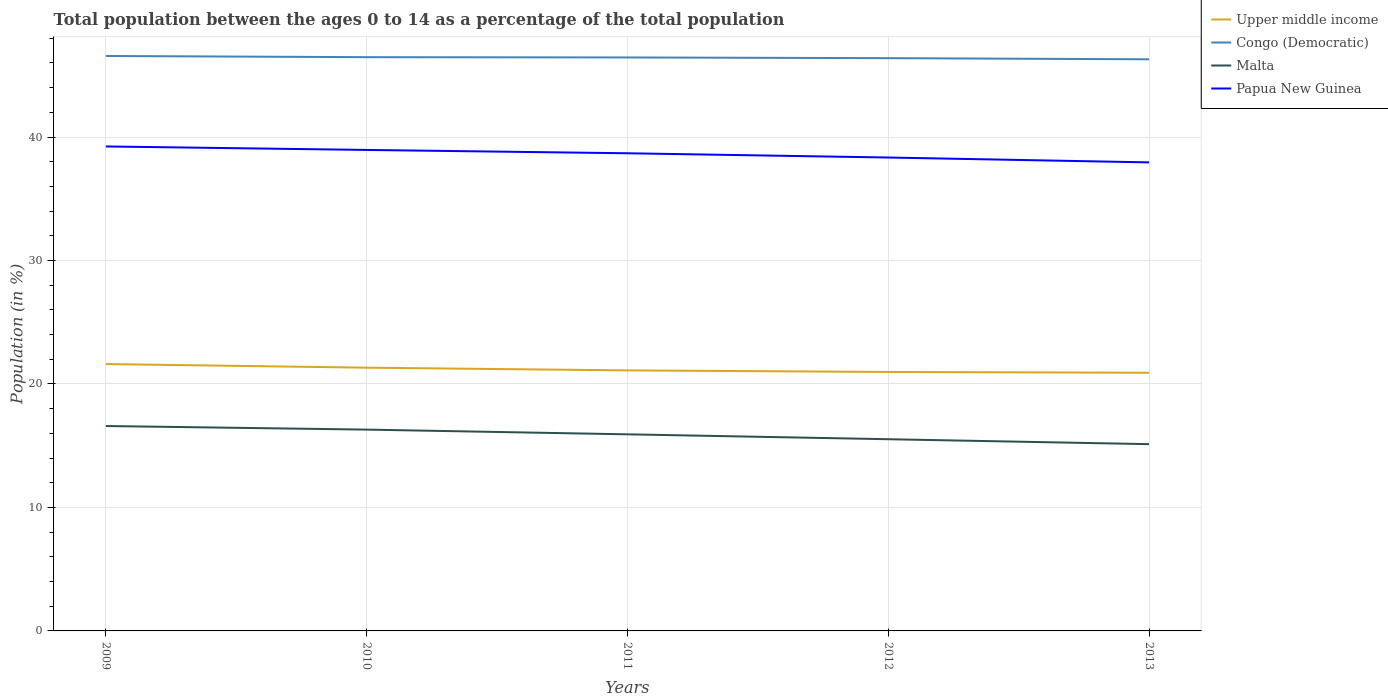Is the number of lines equal to the number of legend labels?
Your answer should be very brief. Yes. Across all years, what is the maximum percentage of the population ages 0 to 14 in Malta?
Keep it short and to the point. 15.13. What is the total percentage of the population ages 0 to 14 in Upper middle income in the graph?
Give a very brief answer. 0.7. What is the difference between the highest and the second highest percentage of the population ages 0 to 14 in Malta?
Provide a succinct answer. 1.47. How many lines are there?
Offer a very short reply. 4. Does the graph contain any zero values?
Your response must be concise. No. Where does the legend appear in the graph?
Your response must be concise. Top right. How many legend labels are there?
Offer a very short reply. 4. How are the legend labels stacked?
Offer a very short reply. Vertical. What is the title of the graph?
Provide a succinct answer. Total population between the ages 0 to 14 as a percentage of the total population. What is the label or title of the X-axis?
Give a very brief answer. Years. What is the label or title of the Y-axis?
Give a very brief answer. Population (in %). What is the Population (in %) of Upper middle income in 2009?
Make the answer very short. 21.61. What is the Population (in %) of Congo (Democratic) in 2009?
Give a very brief answer. 46.56. What is the Population (in %) in Malta in 2009?
Provide a succinct answer. 16.6. What is the Population (in %) of Papua New Guinea in 2009?
Give a very brief answer. 39.24. What is the Population (in %) in Upper middle income in 2010?
Keep it short and to the point. 21.32. What is the Population (in %) in Congo (Democratic) in 2010?
Ensure brevity in your answer.  46.47. What is the Population (in %) in Malta in 2010?
Offer a terse response. 16.3. What is the Population (in %) in Papua New Guinea in 2010?
Make the answer very short. 38.95. What is the Population (in %) of Upper middle income in 2011?
Ensure brevity in your answer.  21.1. What is the Population (in %) of Congo (Democratic) in 2011?
Make the answer very short. 46.45. What is the Population (in %) of Malta in 2011?
Make the answer very short. 15.92. What is the Population (in %) in Papua New Guinea in 2011?
Your answer should be very brief. 38.69. What is the Population (in %) in Upper middle income in 2012?
Make the answer very short. 20.97. What is the Population (in %) of Congo (Democratic) in 2012?
Give a very brief answer. 46.39. What is the Population (in %) in Malta in 2012?
Make the answer very short. 15.53. What is the Population (in %) of Papua New Guinea in 2012?
Offer a terse response. 38.34. What is the Population (in %) in Upper middle income in 2013?
Give a very brief answer. 20.91. What is the Population (in %) in Congo (Democratic) in 2013?
Make the answer very short. 46.3. What is the Population (in %) in Malta in 2013?
Offer a very short reply. 15.13. What is the Population (in %) in Papua New Guinea in 2013?
Keep it short and to the point. 37.95. Across all years, what is the maximum Population (in %) of Upper middle income?
Keep it short and to the point. 21.61. Across all years, what is the maximum Population (in %) in Congo (Democratic)?
Your answer should be compact. 46.56. Across all years, what is the maximum Population (in %) of Malta?
Provide a succinct answer. 16.6. Across all years, what is the maximum Population (in %) in Papua New Guinea?
Ensure brevity in your answer.  39.24. Across all years, what is the minimum Population (in %) in Upper middle income?
Offer a very short reply. 20.91. Across all years, what is the minimum Population (in %) in Congo (Democratic)?
Ensure brevity in your answer.  46.3. Across all years, what is the minimum Population (in %) in Malta?
Give a very brief answer. 15.13. Across all years, what is the minimum Population (in %) in Papua New Guinea?
Ensure brevity in your answer.  37.95. What is the total Population (in %) in Upper middle income in the graph?
Offer a very short reply. 105.92. What is the total Population (in %) in Congo (Democratic) in the graph?
Provide a short and direct response. 232.16. What is the total Population (in %) of Malta in the graph?
Make the answer very short. 79.47. What is the total Population (in %) in Papua New Guinea in the graph?
Keep it short and to the point. 193.17. What is the difference between the Population (in %) in Upper middle income in 2009 and that in 2010?
Your answer should be compact. 0.29. What is the difference between the Population (in %) in Congo (Democratic) in 2009 and that in 2010?
Ensure brevity in your answer.  0.1. What is the difference between the Population (in %) of Malta in 2009 and that in 2010?
Make the answer very short. 0.29. What is the difference between the Population (in %) in Papua New Guinea in 2009 and that in 2010?
Keep it short and to the point. 0.28. What is the difference between the Population (in %) of Upper middle income in 2009 and that in 2011?
Ensure brevity in your answer.  0.51. What is the difference between the Population (in %) in Congo (Democratic) in 2009 and that in 2011?
Provide a succinct answer. 0.12. What is the difference between the Population (in %) in Malta in 2009 and that in 2011?
Offer a terse response. 0.67. What is the difference between the Population (in %) in Papua New Guinea in 2009 and that in 2011?
Give a very brief answer. 0.55. What is the difference between the Population (in %) of Upper middle income in 2009 and that in 2012?
Your answer should be compact. 0.64. What is the difference between the Population (in %) in Congo (Democratic) in 2009 and that in 2012?
Make the answer very short. 0.18. What is the difference between the Population (in %) in Malta in 2009 and that in 2012?
Provide a succinct answer. 1.07. What is the difference between the Population (in %) in Papua New Guinea in 2009 and that in 2012?
Ensure brevity in your answer.  0.9. What is the difference between the Population (in %) of Upper middle income in 2009 and that in 2013?
Your answer should be compact. 0.7. What is the difference between the Population (in %) in Congo (Democratic) in 2009 and that in 2013?
Keep it short and to the point. 0.27. What is the difference between the Population (in %) of Malta in 2009 and that in 2013?
Offer a terse response. 1.47. What is the difference between the Population (in %) in Papua New Guinea in 2009 and that in 2013?
Ensure brevity in your answer.  1.29. What is the difference between the Population (in %) in Upper middle income in 2010 and that in 2011?
Offer a very short reply. 0.22. What is the difference between the Population (in %) of Congo (Democratic) in 2010 and that in 2011?
Provide a short and direct response. 0.02. What is the difference between the Population (in %) of Malta in 2010 and that in 2011?
Your response must be concise. 0.38. What is the difference between the Population (in %) in Papua New Guinea in 2010 and that in 2011?
Provide a succinct answer. 0.27. What is the difference between the Population (in %) in Upper middle income in 2010 and that in 2012?
Provide a succinct answer. 0.35. What is the difference between the Population (in %) in Congo (Democratic) in 2010 and that in 2012?
Provide a succinct answer. 0.08. What is the difference between the Population (in %) of Malta in 2010 and that in 2012?
Offer a terse response. 0.78. What is the difference between the Population (in %) of Papua New Guinea in 2010 and that in 2012?
Your response must be concise. 0.61. What is the difference between the Population (in %) of Upper middle income in 2010 and that in 2013?
Your answer should be compact. 0.41. What is the difference between the Population (in %) in Congo (Democratic) in 2010 and that in 2013?
Ensure brevity in your answer.  0.17. What is the difference between the Population (in %) of Malta in 2010 and that in 2013?
Give a very brief answer. 1.18. What is the difference between the Population (in %) in Papua New Guinea in 2010 and that in 2013?
Your answer should be compact. 1.01. What is the difference between the Population (in %) of Upper middle income in 2011 and that in 2012?
Give a very brief answer. 0.13. What is the difference between the Population (in %) of Congo (Democratic) in 2011 and that in 2012?
Keep it short and to the point. 0.06. What is the difference between the Population (in %) of Malta in 2011 and that in 2012?
Your response must be concise. 0.4. What is the difference between the Population (in %) of Papua New Guinea in 2011 and that in 2012?
Make the answer very short. 0.34. What is the difference between the Population (in %) in Upper middle income in 2011 and that in 2013?
Your answer should be compact. 0.19. What is the difference between the Population (in %) of Congo (Democratic) in 2011 and that in 2013?
Offer a terse response. 0.15. What is the difference between the Population (in %) of Malta in 2011 and that in 2013?
Your answer should be very brief. 0.8. What is the difference between the Population (in %) in Papua New Guinea in 2011 and that in 2013?
Your answer should be compact. 0.74. What is the difference between the Population (in %) of Upper middle income in 2012 and that in 2013?
Your answer should be very brief. 0.06. What is the difference between the Population (in %) in Congo (Democratic) in 2012 and that in 2013?
Offer a very short reply. 0.09. What is the difference between the Population (in %) in Malta in 2012 and that in 2013?
Offer a terse response. 0.4. What is the difference between the Population (in %) in Papua New Guinea in 2012 and that in 2013?
Offer a terse response. 0.4. What is the difference between the Population (in %) of Upper middle income in 2009 and the Population (in %) of Congo (Democratic) in 2010?
Provide a short and direct response. -24.86. What is the difference between the Population (in %) in Upper middle income in 2009 and the Population (in %) in Malta in 2010?
Your answer should be very brief. 5.31. What is the difference between the Population (in %) of Upper middle income in 2009 and the Population (in %) of Papua New Guinea in 2010?
Your response must be concise. -17.34. What is the difference between the Population (in %) of Congo (Democratic) in 2009 and the Population (in %) of Malta in 2010?
Provide a short and direct response. 30.26. What is the difference between the Population (in %) in Congo (Democratic) in 2009 and the Population (in %) in Papua New Guinea in 2010?
Your answer should be compact. 7.61. What is the difference between the Population (in %) in Malta in 2009 and the Population (in %) in Papua New Guinea in 2010?
Your response must be concise. -22.36. What is the difference between the Population (in %) in Upper middle income in 2009 and the Population (in %) in Congo (Democratic) in 2011?
Give a very brief answer. -24.83. What is the difference between the Population (in %) of Upper middle income in 2009 and the Population (in %) of Malta in 2011?
Make the answer very short. 5.69. What is the difference between the Population (in %) in Upper middle income in 2009 and the Population (in %) in Papua New Guinea in 2011?
Make the answer very short. -17.07. What is the difference between the Population (in %) in Congo (Democratic) in 2009 and the Population (in %) in Malta in 2011?
Offer a very short reply. 30.64. What is the difference between the Population (in %) of Congo (Democratic) in 2009 and the Population (in %) of Papua New Guinea in 2011?
Provide a short and direct response. 7.88. What is the difference between the Population (in %) of Malta in 2009 and the Population (in %) of Papua New Guinea in 2011?
Offer a very short reply. -22.09. What is the difference between the Population (in %) in Upper middle income in 2009 and the Population (in %) in Congo (Democratic) in 2012?
Offer a terse response. -24.77. What is the difference between the Population (in %) in Upper middle income in 2009 and the Population (in %) in Malta in 2012?
Provide a succinct answer. 6.09. What is the difference between the Population (in %) in Upper middle income in 2009 and the Population (in %) in Papua New Guinea in 2012?
Your response must be concise. -16.73. What is the difference between the Population (in %) of Congo (Democratic) in 2009 and the Population (in %) of Malta in 2012?
Give a very brief answer. 31.04. What is the difference between the Population (in %) of Congo (Democratic) in 2009 and the Population (in %) of Papua New Guinea in 2012?
Provide a short and direct response. 8.22. What is the difference between the Population (in %) in Malta in 2009 and the Population (in %) in Papua New Guinea in 2012?
Your answer should be compact. -21.75. What is the difference between the Population (in %) in Upper middle income in 2009 and the Population (in %) in Congo (Democratic) in 2013?
Give a very brief answer. -24.68. What is the difference between the Population (in %) in Upper middle income in 2009 and the Population (in %) in Malta in 2013?
Offer a very short reply. 6.49. What is the difference between the Population (in %) of Upper middle income in 2009 and the Population (in %) of Papua New Guinea in 2013?
Keep it short and to the point. -16.33. What is the difference between the Population (in %) of Congo (Democratic) in 2009 and the Population (in %) of Malta in 2013?
Give a very brief answer. 31.44. What is the difference between the Population (in %) of Congo (Democratic) in 2009 and the Population (in %) of Papua New Guinea in 2013?
Provide a short and direct response. 8.62. What is the difference between the Population (in %) of Malta in 2009 and the Population (in %) of Papua New Guinea in 2013?
Provide a succinct answer. -21.35. What is the difference between the Population (in %) of Upper middle income in 2010 and the Population (in %) of Congo (Democratic) in 2011?
Offer a very short reply. -25.13. What is the difference between the Population (in %) in Upper middle income in 2010 and the Population (in %) in Malta in 2011?
Keep it short and to the point. 5.4. What is the difference between the Population (in %) of Upper middle income in 2010 and the Population (in %) of Papua New Guinea in 2011?
Give a very brief answer. -17.37. What is the difference between the Population (in %) in Congo (Democratic) in 2010 and the Population (in %) in Malta in 2011?
Your answer should be very brief. 30.55. What is the difference between the Population (in %) in Congo (Democratic) in 2010 and the Population (in %) in Papua New Guinea in 2011?
Make the answer very short. 7.78. What is the difference between the Population (in %) of Malta in 2010 and the Population (in %) of Papua New Guinea in 2011?
Provide a short and direct response. -22.38. What is the difference between the Population (in %) of Upper middle income in 2010 and the Population (in %) of Congo (Democratic) in 2012?
Your response must be concise. -25.07. What is the difference between the Population (in %) of Upper middle income in 2010 and the Population (in %) of Malta in 2012?
Make the answer very short. 5.79. What is the difference between the Population (in %) of Upper middle income in 2010 and the Population (in %) of Papua New Guinea in 2012?
Ensure brevity in your answer.  -17.02. What is the difference between the Population (in %) in Congo (Democratic) in 2010 and the Population (in %) in Malta in 2012?
Make the answer very short. 30.94. What is the difference between the Population (in %) of Congo (Democratic) in 2010 and the Population (in %) of Papua New Guinea in 2012?
Your answer should be very brief. 8.13. What is the difference between the Population (in %) of Malta in 2010 and the Population (in %) of Papua New Guinea in 2012?
Give a very brief answer. -22.04. What is the difference between the Population (in %) of Upper middle income in 2010 and the Population (in %) of Congo (Democratic) in 2013?
Provide a short and direct response. -24.98. What is the difference between the Population (in %) of Upper middle income in 2010 and the Population (in %) of Malta in 2013?
Your answer should be compact. 6.19. What is the difference between the Population (in %) of Upper middle income in 2010 and the Population (in %) of Papua New Guinea in 2013?
Provide a short and direct response. -16.63. What is the difference between the Population (in %) of Congo (Democratic) in 2010 and the Population (in %) of Malta in 2013?
Keep it short and to the point. 31.34. What is the difference between the Population (in %) of Congo (Democratic) in 2010 and the Population (in %) of Papua New Guinea in 2013?
Give a very brief answer. 8.52. What is the difference between the Population (in %) in Malta in 2010 and the Population (in %) in Papua New Guinea in 2013?
Keep it short and to the point. -21.64. What is the difference between the Population (in %) in Upper middle income in 2011 and the Population (in %) in Congo (Democratic) in 2012?
Keep it short and to the point. -25.29. What is the difference between the Population (in %) of Upper middle income in 2011 and the Population (in %) of Malta in 2012?
Make the answer very short. 5.57. What is the difference between the Population (in %) of Upper middle income in 2011 and the Population (in %) of Papua New Guinea in 2012?
Give a very brief answer. -17.24. What is the difference between the Population (in %) in Congo (Democratic) in 2011 and the Population (in %) in Malta in 2012?
Offer a very short reply. 30.92. What is the difference between the Population (in %) of Congo (Democratic) in 2011 and the Population (in %) of Papua New Guinea in 2012?
Offer a very short reply. 8.1. What is the difference between the Population (in %) in Malta in 2011 and the Population (in %) in Papua New Guinea in 2012?
Offer a terse response. -22.42. What is the difference between the Population (in %) of Upper middle income in 2011 and the Population (in %) of Congo (Democratic) in 2013?
Provide a succinct answer. -25.2. What is the difference between the Population (in %) of Upper middle income in 2011 and the Population (in %) of Malta in 2013?
Make the answer very short. 5.98. What is the difference between the Population (in %) of Upper middle income in 2011 and the Population (in %) of Papua New Guinea in 2013?
Give a very brief answer. -16.85. What is the difference between the Population (in %) in Congo (Democratic) in 2011 and the Population (in %) in Malta in 2013?
Your answer should be compact. 31.32. What is the difference between the Population (in %) of Congo (Democratic) in 2011 and the Population (in %) of Papua New Guinea in 2013?
Offer a terse response. 8.5. What is the difference between the Population (in %) of Malta in 2011 and the Population (in %) of Papua New Guinea in 2013?
Provide a short and direct response. -22.02. What is the difference between the Population (in %) in Upper middle income in 2012 and the Population (in %) in Congo (Democratic) in 2013?
Keep it short and to the point. -25.32. What is the difference between the Population (in %) of Upper middle income in 2012 and the Population (in %) of Malta in 2013?
Offer a terse response. 5.85. What is the difference between the Population (in %) in Upper middle income in 2012 and the Population (in %) in Papua New Guinea in 2013?
Give a very brief answer. -16.97. What is the difference between the Population (in %) of Congo (Democratic) in 2012 and the Population (in %) of Malta in 2013?
Keep it short and to the point. 31.26. What is the difference between the Population (in %) of Congo (Democratic) in 2012 and the Population (in %) of Papua New Guinea in 2013?
Make the answer very short. 8.44. What is the difference between the Population (in %) in Malta in 2012 and the Population (in %) in Papua New Guinea in 2013?
Give a very brief answer. -22.42. What is the average Population (in %) of Upper middle income per year?
Provide a short and direct response. 21.18. What is the average Population (in %) in Congo (Democratic) per year?
Ensure brevity in your answer.  46.43. What is the average Population (in %) in Malta per year?
Make the answer very short. 15.89. What is the average Population (in %) of Papua New Guinea per year?
Provide a short and direct response. 38.63. In the year 2009, what is the difference between the Population (in %) of Upper middle income and Population (in %) of Congo (Democratic)?
Make the answer very short. -24.95. In the year 2009, what is the difference between the Population (in %) of Upper middle income and Population (in %) of Malta?
Give a very brief answer. 5.02. In the year 2009, what is the difference between the Population (in %) in Upper middle income and Population (in %) in Papua New Guinea?
Make the answer very short. -17.62. In the year 2009, what is the difference between the Population (in %) in Congo (Democratic) and Population (in %) in Malta?
Your answer should be compact. 29.97. In the year 2009, what is the difference between the Population (in %) in Congo (Democratic) and Population (in %) in Papua New Guinea?
Give a very brief answer. 7.33. In the year 2009, what is the difference between the Population (in %) of Malta and Population (in %) of Papua New Guinea?
Provide a succinct answer. -22.64. In the year 2010, what is the difference between the Population (in %) of Upper middle income and Population (in %) of Congo (Democratic)?
Provide a succinct answer. -25.15. In the year 2010, what is the difference between the Population (in %) in Upper middle income and Population (in %) in Malta?
Offer a very short reply. 5.02. In the year 2010, what is the difference between the Population (in %) in Upper middle income and Population (in %) in Papua New Guinea?
Make the answer very short. -17.63. In the year 2010, what is the difference between the Population (in %) in Congo (Democratic) and Population (in %) in Malta?
Your answer should be very brief. 30.16. In the year 2010, what is the difference between the Population (in %) of Congo (Democratic) and Population (in %) of Papua New Guinea?
Provide a succinct answer. 7.51. In the year 2010, what is the difference between the Population (in %) in Malta and Population (in %) in Papua New Guinea?
Your answer should be compact. -22.65. In the year 2011, what is the difference between the Population (in %) of Upper middle income and Population (in %) of Congo (Democratic)?
Offer a terse response. -25.34. In the year 2011, what is the difference between the Population (in %) of Upper middle income and Population (in %) of Malta?
Offer a very short reply. 5.18. In the year 2011, what is the difference between the Population (in %) in Upper middle income and Population (in %) in Papua New Guinea?
Your answer should be compact. -17.59. In the year 2011, what is the difference between the Population (in %) in Congo (Democratic) and Population (in %) in Malta?
Make the answer very short. 30.52. In the year 2011, what is the difference between the Population (in %) in Congo (Democratic) and Population (in %) in Papua New Guinea?
Offer a terse response. 7.76. In the year 2011, what is the difference between the Population (in %) in Malta and Population (in %) in Papua New Guinea?
Ensure brevity in your answer.  -22.76. In the year 2012, what is the difference between the Population (in %) of Upper middle income and Population (in %) of Congo (Democratic)?
Your answer should be very brief. -25.41. In the year 2012, what is the difference between the Population (in %) in Upper middle income and Population (in %) in Malta?
Offer a terse response. 5.45. In the year 2012, what is the difference between the Population (in %) of Upper middle income and Population (in %) of Papua New Guinea?
Offer a very short reply. -17.37. In the year 2012, what is the difference between the Population (in %) in Congo (Democratic) and Population (in %) in Malta?
Provide a succinct answer. 30.86. In the year 2012, what is the difference between the Population (in %) of Congo (Democratic) and Population (in %) of Papua New Guinea?
Provide a short and direct response. 8.05. In the year 2012, what is the difference between the Population (in %) in Malta and Population (in %) in Papua New Guinea?
Provide a succinct answer. -22.81. In the year 2013, what is the difference between the Population (in %) in Upper middle income and Population (in %) in Congo (Democratic)?
Make the answer very short. -25.39. In the year 2013, what is the difference between the Population (in %) of Upper middle income and Population (in %) of Malta?
Offer a very short reply. 5.78. In the year 2013, what is the difference between the Population (in %) in Upper middle income and Population (in %) in Papua New Guinea?
Give a very brief answer. -17.04. In the year 2013, what is the difference between the Population (in %) of Congo (Democratic) and Population (in %) of Malta?
Keep it short and to the point. 31.17. In the year 2013, what is the difference between the Population (in %) in Congo (Democratic) and Population (in %) in Papua New Guinea?
Give a very brief answer. 8.35. In the year 2013, what is the difference between the Population (in %) in Malta and Population (in %) in Papua New Guinea?
Keep it short and to the point. -22.82. What is the ratio of the Population (in %) in Upper middle income in 2009 to that in 2010?
Provide a succinct answer. 1.01. What is the ratio of the Population (in %) in Malta in 2009 to that in 2010?
Your answer should be compact. 1.02. What is the ratio of the Population (in %) of Papua New Guinea in 2009 to that in 2010?
Offer a terse response. 1.01. What is the ratio of the Population (in %) of Upper middle income in 2009 to that in 2011?
Provide a short and direct response. 1.02. What is the ratio of the Population (in %) in Malta in 2009 to that in 2011?
Make the answer very short. 1.04. What is the ratio of the Population (in %) of Papua New Guinea in 2009 to that in 2011?
Offer a terse response. 1.01. What is the ratio of the Population (in %) in Upper middle income in 2009 to that in 2012?
Offer a terse response. 1.03. What is the ratio of the Population (in %) in Malta in 2009 to that in 2012?
Your response must be concise. 1.07. What is the ratio of the Population (in %) of Papua New Guinea in 2009 to that in 2012?
Provide a succinct answer. 1.02. What is the ratio of the Population (in %) in Upper middle income in 2009 to that in 2013?
Give a very brief answer. 1.03. What is the ratio of the Population (in %) of Malta in 2009 to that in 2013?
Your answer should be compact. 1.1. What is the ratio of the Population (in %) of Papua New Guinea in 2009 to that in 2013?
Offer a terse response. 1.03. What is the ratio of the Population (in %) in Upper middle income in 2010 to that in 2011?
Ensure brevity in your answer.  1.01. What is the ratio of the Population (in %) of Malta in 2010 to that in 2011?
Your answer should be compact. 1.02. What is the ratio of the Population (in %) of Upper middle income in 2010 to that in 2012?
Make the answer very short. 1.02. What is the ratio of the Population (in %) in Congo (Democratic) in 2010 to that in 2012?
Provide a succinct answer. 1. What is the ratio of the Population (in %) in Malta in 2010 to that in 2012?
Make the answer very short. 1.05. What is the ratio of the Population (in %) in Upper middle income in 2010 to that in 2013?
Your answer should be very brief. 1.02. What is the ratio of the Population (in %) in Malta in 2010 to that in 2013?
Your answer should be very brief. 1.08. What is the ratio of the Population (in %) of Papua New Guinea in 2010 to that in 2013?
Offer a terse response. 1.03. What is the ratio of the Population (in %) of Malta in 2011 to that in 2012?
Your answer should be very brief. 1.03. What is the ratio of the Population (in %) in Papua New Guinea in 2011 to that in 2012?
Your answer should be very brief. 1.01. What is the ratio of the Population (in %) in Upper middle income in 2011 to that in 2013?
Offer a terse response. 1.01. What is the ratio of the Population (in %) of Malta in 2011 to that in 2013?
Offer a terse response. 1.05. What is the ratio of the Population (in %) in Papua New Guinea in 2011 to that in 2013?
Your answer should be very brief. 1.02. What is the ratio of the Population (in %) of Upper middle income in 2012 to that in 2013?
Make the answer very short. 1. What is the ratio of the Population (in %) in Congo (Democratic) in 2012 to that in 2013?
Give a very brief answer. 1. What is the ratio of the Population (in %) of Malta in 2012 to that in 2013?
Ensure brevity in your answer.  1.03. What is the ratio of the Population (in %) of Papua New Guinea in 2012 to that in 2013?
Make the answer very short. 1.01. What is the difference between the highest and the second highest Population (in %) of Upper middle income?
Give a very brief answer. 0.29. What is the difference between the highest and the second highest Population (in %) of Congo (Democratic)?
Keep it short and to the point. 0.1. What is the difference between the highest and the second highest Population (in %) in Malta?
Make the answer very short. 0.29. What is the difference between the highest and the second highest Population (in %) in Papua New Guinea?
Keep it short and to the point. 0.28. What is the difference between the highest and the lowest Population (in %) of Upper middle income?
Make the answer very short. 0.7. What is the difference between the highest and the lowest Population (in %) of Congo (Democratic)?
Provide a succinct answer. 0.27. What is the difference between the highest and the lowest Population (in %) in Malta?
Make the answer very short. 1.47. What is the difference between the highest and the lowest Population (in %) in Papua New Guinea?
Your answer should be compact. 1.29. 